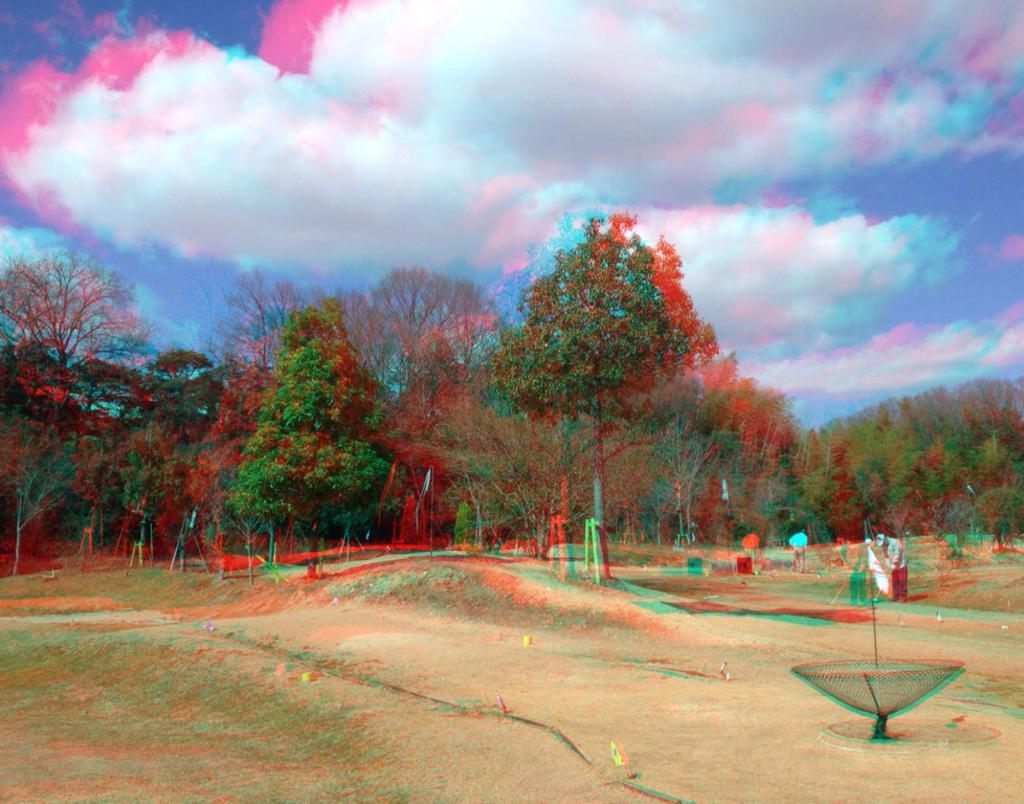Who or what can be seen in the image? There are people in the image. What is on the ground in the image? There are objects on the ground in the image. What can be seen in the distance in the image? There are trees visible in the background of the image. What else is visible in the background of the image? The sky is visible in the background of the image, and clouds are present in the sky. What is the crook doing in the image? There is no crook present in the image. What is the rate of the people walking in the image? The image does not show people walking, so it is not possible to determine their rate. 